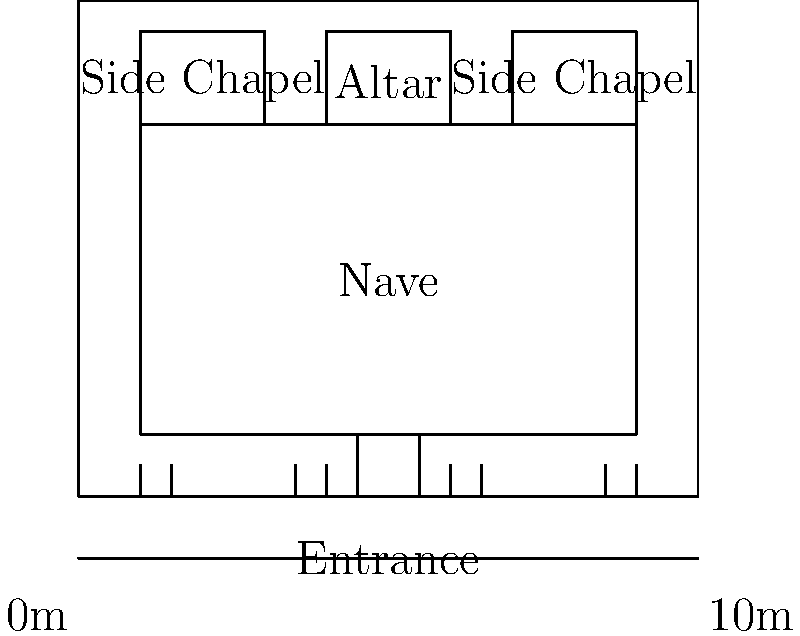In the architectural layout of a typical church in Malibu, what is the central and largest area called, and what is its primary function? To answer this question, let's analyze the architectural layout of a typical church in Malibu:

1. The diagram shows a simplified floor plan of a church.
2. The largest central area in the church is clearly labeled as the "Nave."
3. The Nave is the main body of the church, extending from the entrance to the altar.
4. It is typically a long, rectangular space, which we can see in the diagram.
5. The primary functions of the Nave are:
   a. To accommodate the congregation during services
   b. To provide a clear line of sight to the altar
   c. To create a sense of community and shared worship experience
6. Other important areas of the church, such as the altar and side chapels, are positioned around the Nave, emphasizing its central role.
7. The size and central location of the Nave allow it to serve as the main gathering space for worship activities.

Therefore, the central and largest area in a typical church in Malibu is called the Nave, and its primary function is to accommodate the congregation during worship services.
Answer: The Nave; to accommodate the congregation during worship services. 